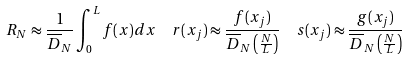<formula> <loc_0><loc_0><loc_500><loc_500>& R _ { N } \approx \frac { 1 } { \overline { D } _ { N } } \int _ { 0 } ^ { L } f ( x ) d x \quad r ( x _ { j } ) \approx \frac { f ( x _ { j } ) } { \overline { D } _ { N } \left ( \frac { N } { L } \right ) } \quad s ( x _ { j } ) \approx \frac { g ( x _ { j } ) } { \overline { D } _ { N } \left ( \frac { N } { L } \right ) }</formula> 